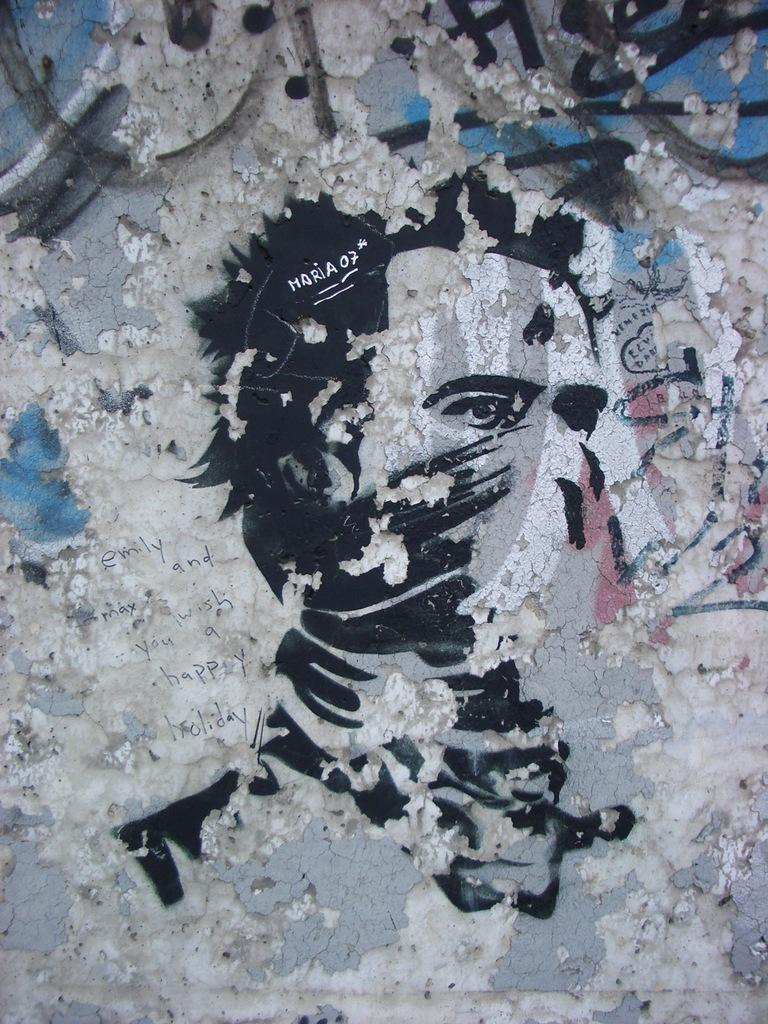What is the main subject of the image? There is a painting in the image. Can you describe any other elements in the image besides the painting? Yes, there is text on the wall in the image. What type of ice can be seen melting on the painting in the image? There is no ice present in the image, and the painting is not depicted as having any ice on it. 